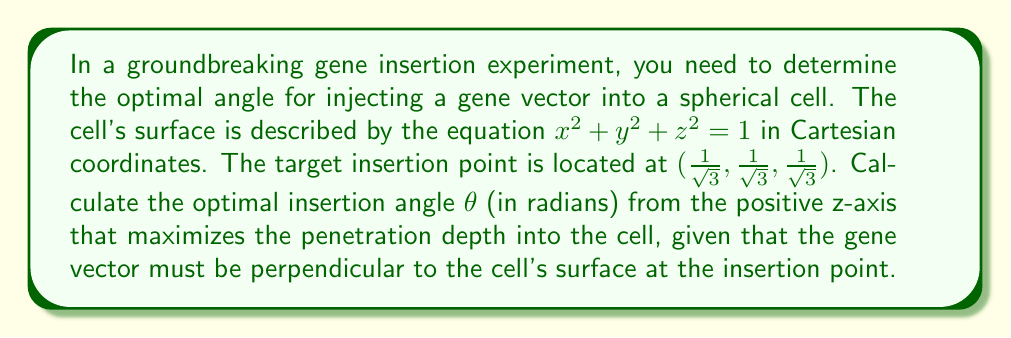Can you answer this question? Let's approach this step-by-step:

1) First, we need to find the normal vector to the surface at the insertion point. The gradient of the sphere's equation gives us the normal vector:

   $$\nabla(x^2 + y^2 + z^2) = (2x, 2y, 2z)$$

   At the insertion point $(\frac{1}{\sqrt{3}}, \frac{1}{\sqrt{3}}, \frac{1}{\sqrt{3}})$, the normal vector is:

   $$\vec{n} = (\frac{2}{\sqrt{3}}, \frac{2}{\sqrt{3}}, \frac{2}{\sqrt{3}})$$

2) We can normalize this vector:

   $$\vec{n}_{\text{norm}} = (\frac{1}{\sqrt{3}}, \frac{1}{\sqrt{3}}, \frac{1}{\sqrt{3}})$$

3) The gene vector must be perpendicular to the cell's surface, so it should align with this normal vector.

4) Now, we need to find the angle $\theta$ between this vector and the positive z-axis. We can use the dot product formula:

   $$\cos\theta = \frac{\vec{n}_{\text{norm}} \cdot \vec{k}}{|\vec{n}_{\text{norm}}||\vec{k}|}$$

   Where $\vec{k}$ is the unit vector in the z-direction $(0, 0, 1)$.

5) Calculating the dot product:

   $$\cos\theta = \frac{(\frac{1}{\sqrt{3}}, \frac{1}{\sqrt{3}}, \frac{1}{\sqrt{3}}) \cdot (0, 0, 1)}{1 \cdot 1} = \frac{1}{\sqrt{3}}$$

6) Therefore:

   $$\theta = \arccos(\frac{1}{\sqrt{3}})$$

This angle maximizes the penetration depth as it aligns the gene vector with the normal to the cell surface at the insertion point.
Answer: $\arccos(\frac{1}{\sqrt{3}})$ radians 